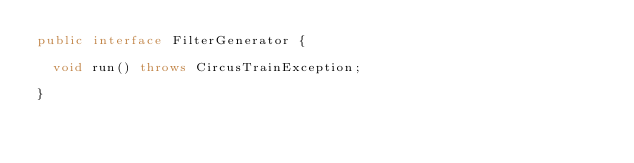<code> <loc_0><loc_0><loc_500><loc_500><_Java_>public interface FilterGenerator {

  void run() throws CircusTrainException;

}
</code> 